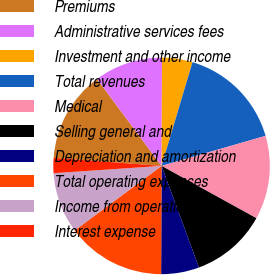Convert chart to OTSL. <chart><loc_0><loc_0><loc_500><loc_500><pie_chart><fcel>Premiums<fcel>Administrative services fees<fcel>Investment and other income<fcel>Total revenues<fcel>Medical<fcel>Selling general and<fcel>Depreciation and amortization<fcel>Total operating expenses<fcel>Income from operations<fcel>Interest expense<nl><fcel>13.64%<fcel>10.23%<fcel>4.55%<fcel>15.91%<fcel>12.5%<fcel>11.36%<fcel>5.68%<fcel>14.77%<fcel>9.09%<fcel>2.27%<nl></chart> 